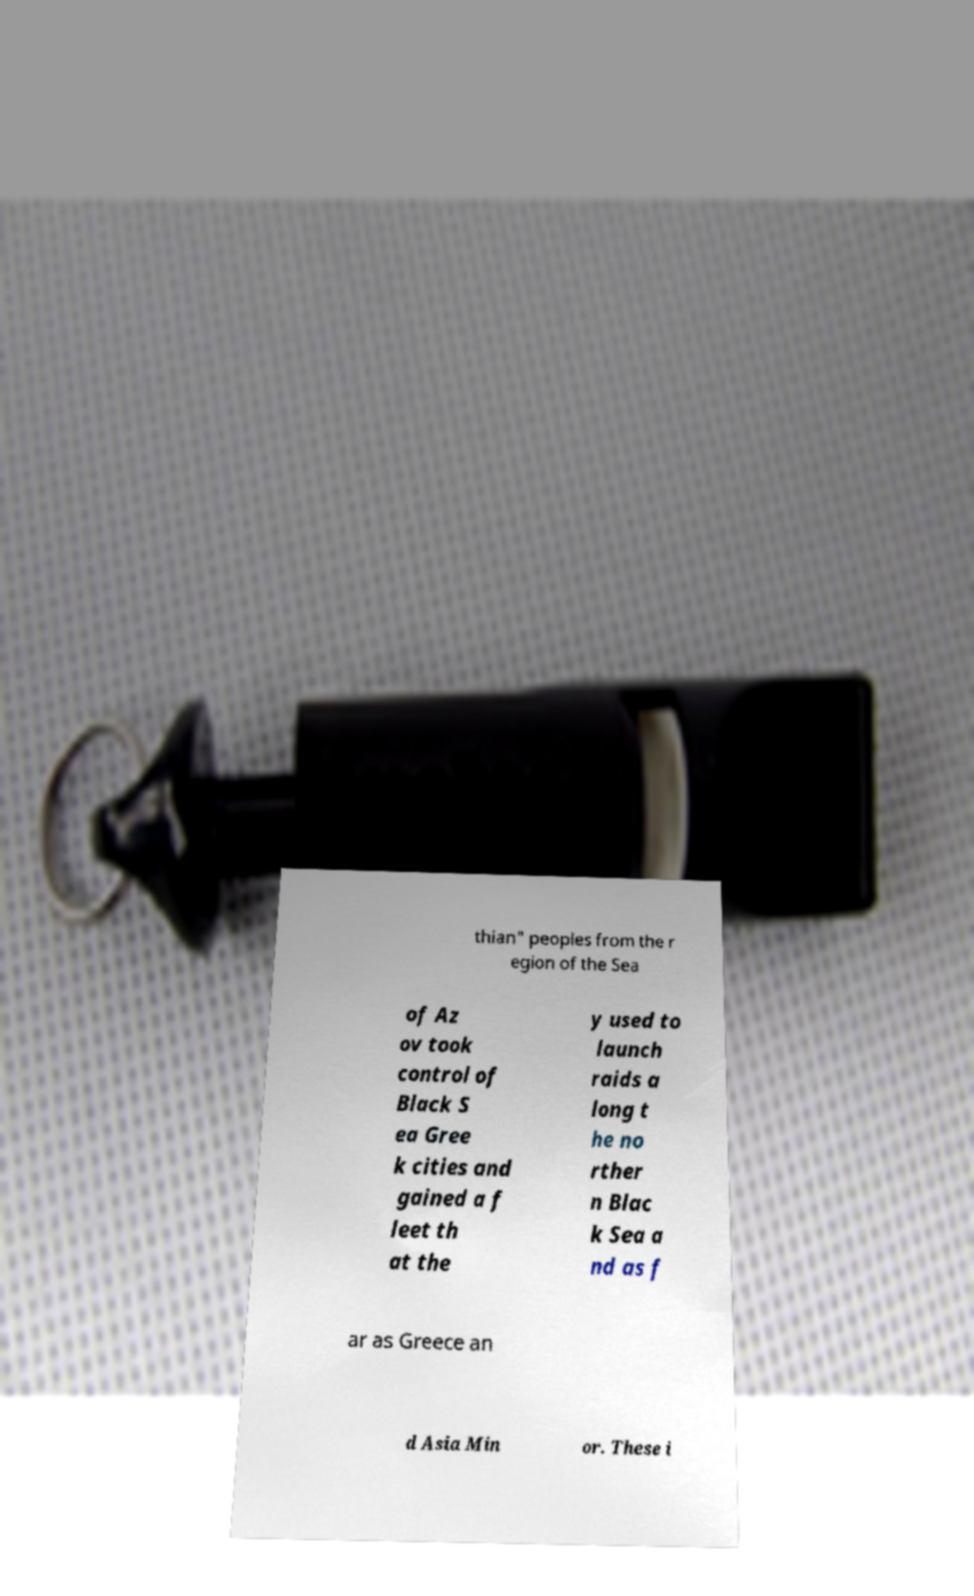Can you accurately transcribe the text from the provided image for me? thian" peoples from the r egion of the Sea of Az ov took control of Black S ea Gree k cities and gained a f leet th at the y used to launch raids a long t he no rther n Blac k Sea a nd as f ar as Greece an d Asia Min or. These i 